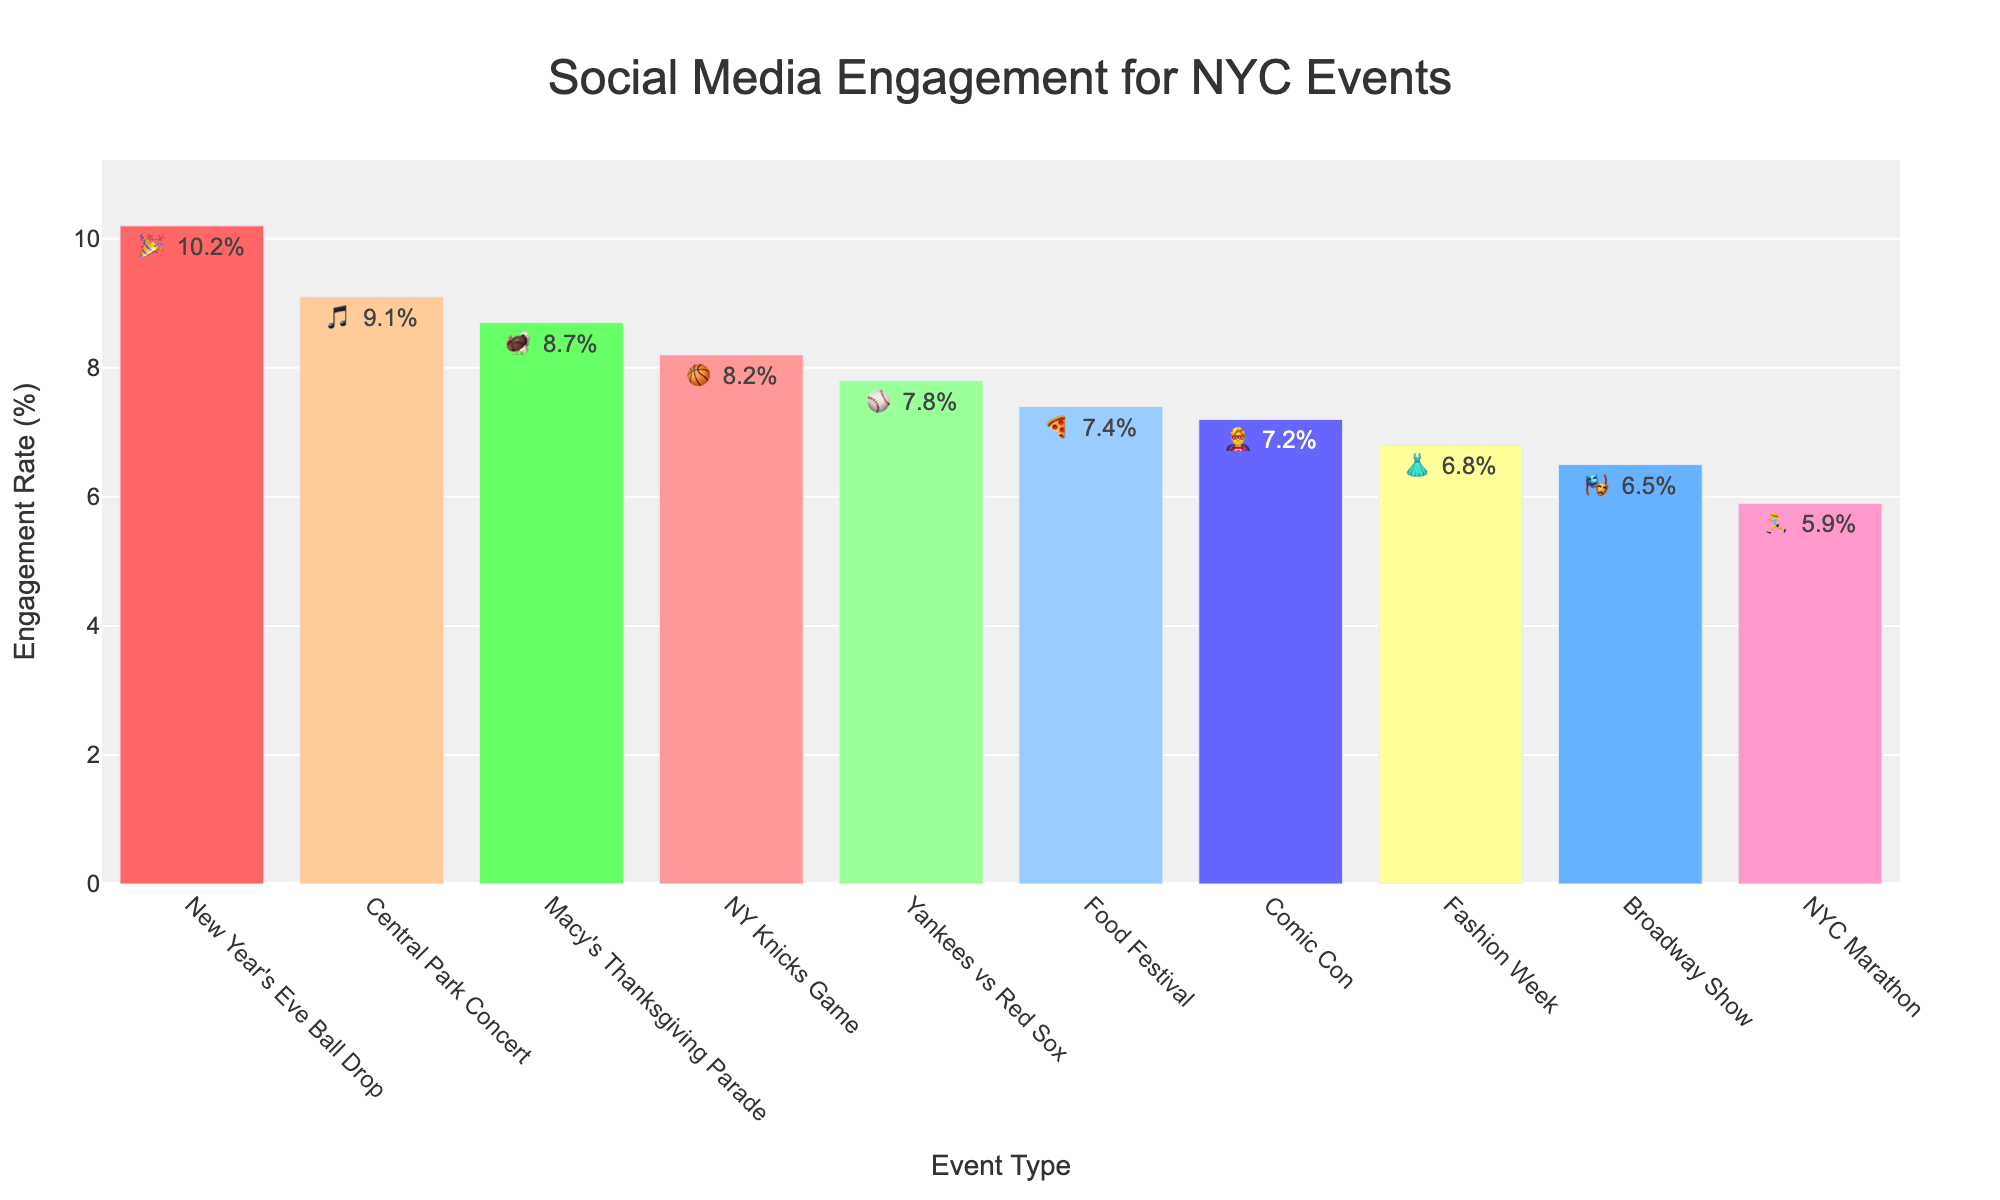What's the title of the figure? The title is displayed at the top of the figure. It reads "Social Media Engagement for NYC Events."
Answer: Social Media Engagement for NYC Events How many event categories are displayed in the figure? Each unique bar represents an events category. By counting them, we see there are 10 event categories.
Answer: 10 Which event has the highest engagement rate? The event with the highest bar in the figure has the highest engagement rate. The "New Year's Eve Ball Drop" has the tallest bar.
Answer: New Year's Eve Ball Drop What’s the engagement rate for the NY Yankees vs Red Sox event? Locate the bar labeled "Yankees vs Red Sox" and check the engagement rate listed next to the emoji on the bar. It shows 7.8%.
Answer: 7.8% Which platform does the Macy's Thanksgiving Parade mostly engage on? Looking at the bar for "Macy's Thanksgiving Parade," it shows an Instagram emoji (🦃).
Answer: Instagram What is the total engagement rate for all Instagram events? Find all bars with the Instagram emoji (🏀, 🎵, 🍕, 🦃). Sum their rates: 8.2 + 9.1 + 7.4 + 8.7 = 33.4%.
Answer: 33.4% How much higher is the engagement rate for the Central Park Concert compared to the NYC Marathon? The Central Park Concert has 9.1% and the NYC Marathon has 5.9%. The difference is 9.1 - 5.9 = 3.2%.
Answer: 3.2% Which event type engages more on Twitter, Broadway Show or Comic Con? Compare the bars for Broadway Show (🎭) and Comic Con (🦸‍♂️). Comic Con has a higher rate (7.2%) compared to Broadway Show (6.5%).
Answer: Comic Con Rank the engagement rates from highest to lowest. Order the events based on their bar heights from tallest to shortest: New Year's Eve Ball Drop > Central Park Concert > Macy's Thanksgiving Parade > NY Knicks Game > Yankees vs Red Sox > Food Festival > Comic Con > Fashion Week > Broadway Show > NYC Marathon.
Answer: New Year's Eve Ball Drop, Central Park Concert, Macy's Thanksgiving Parade, NY Knicks Game, Yankees vs Red Sox, Food Festival, Comic Con, Fashion Week, Broadway Show, NYC Marathon Which Instagram event has the lowest engagement rate? Identify the bars with an Instagram emoji (🏀, 🎵, 🍕, 🦃) and find the one with the shortest bar. The "Food Festival" has the lowest engagement (7.4%).
Answer: Food Festival 